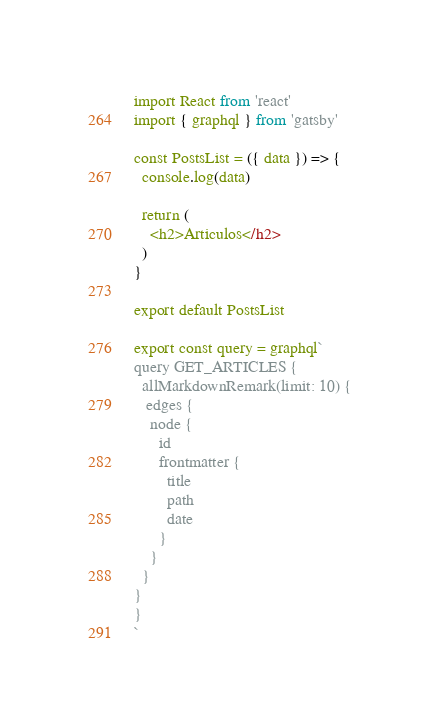Convert code to text. <code><loc_0><loc_0><loc_500><loc_500><_JavaScript_>import React from 'react'
import { graphql } from 'gatsby'

const PostsList = ({ data }) => {
  console.log(data)

  return (
    <h2>Articulos</h2>
  )
}

export default PostsList

export const query = graphql`
query GET_ARTICLES {
  allMarkdownRemark(limit: 10) {
   edges {
    node {
      id
      frontmatter {
        title
        path
        date
      }
    }
  }
}
}
`
</code> 